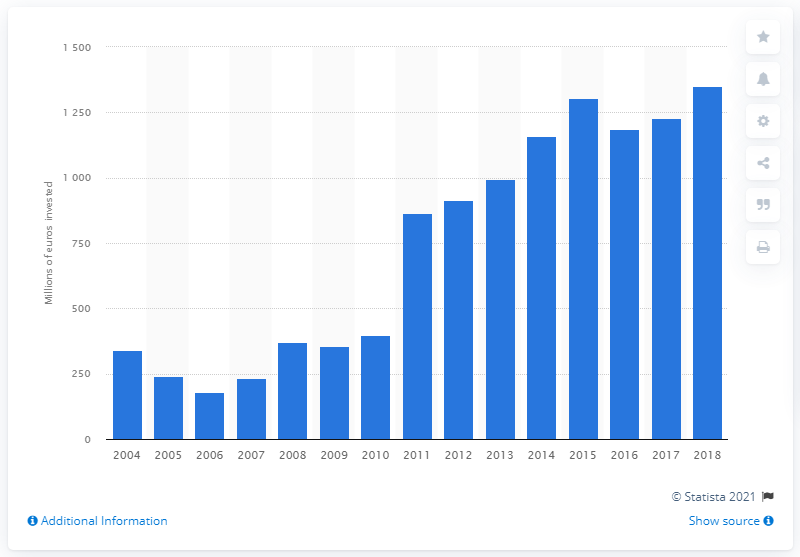Identify some key points in this picture. The lowest investment volume in Denmark was recorded in 2006. According to data from 2018, approximately 1351 dollars were spent on improving the rail network infrastructure in Denmark. 